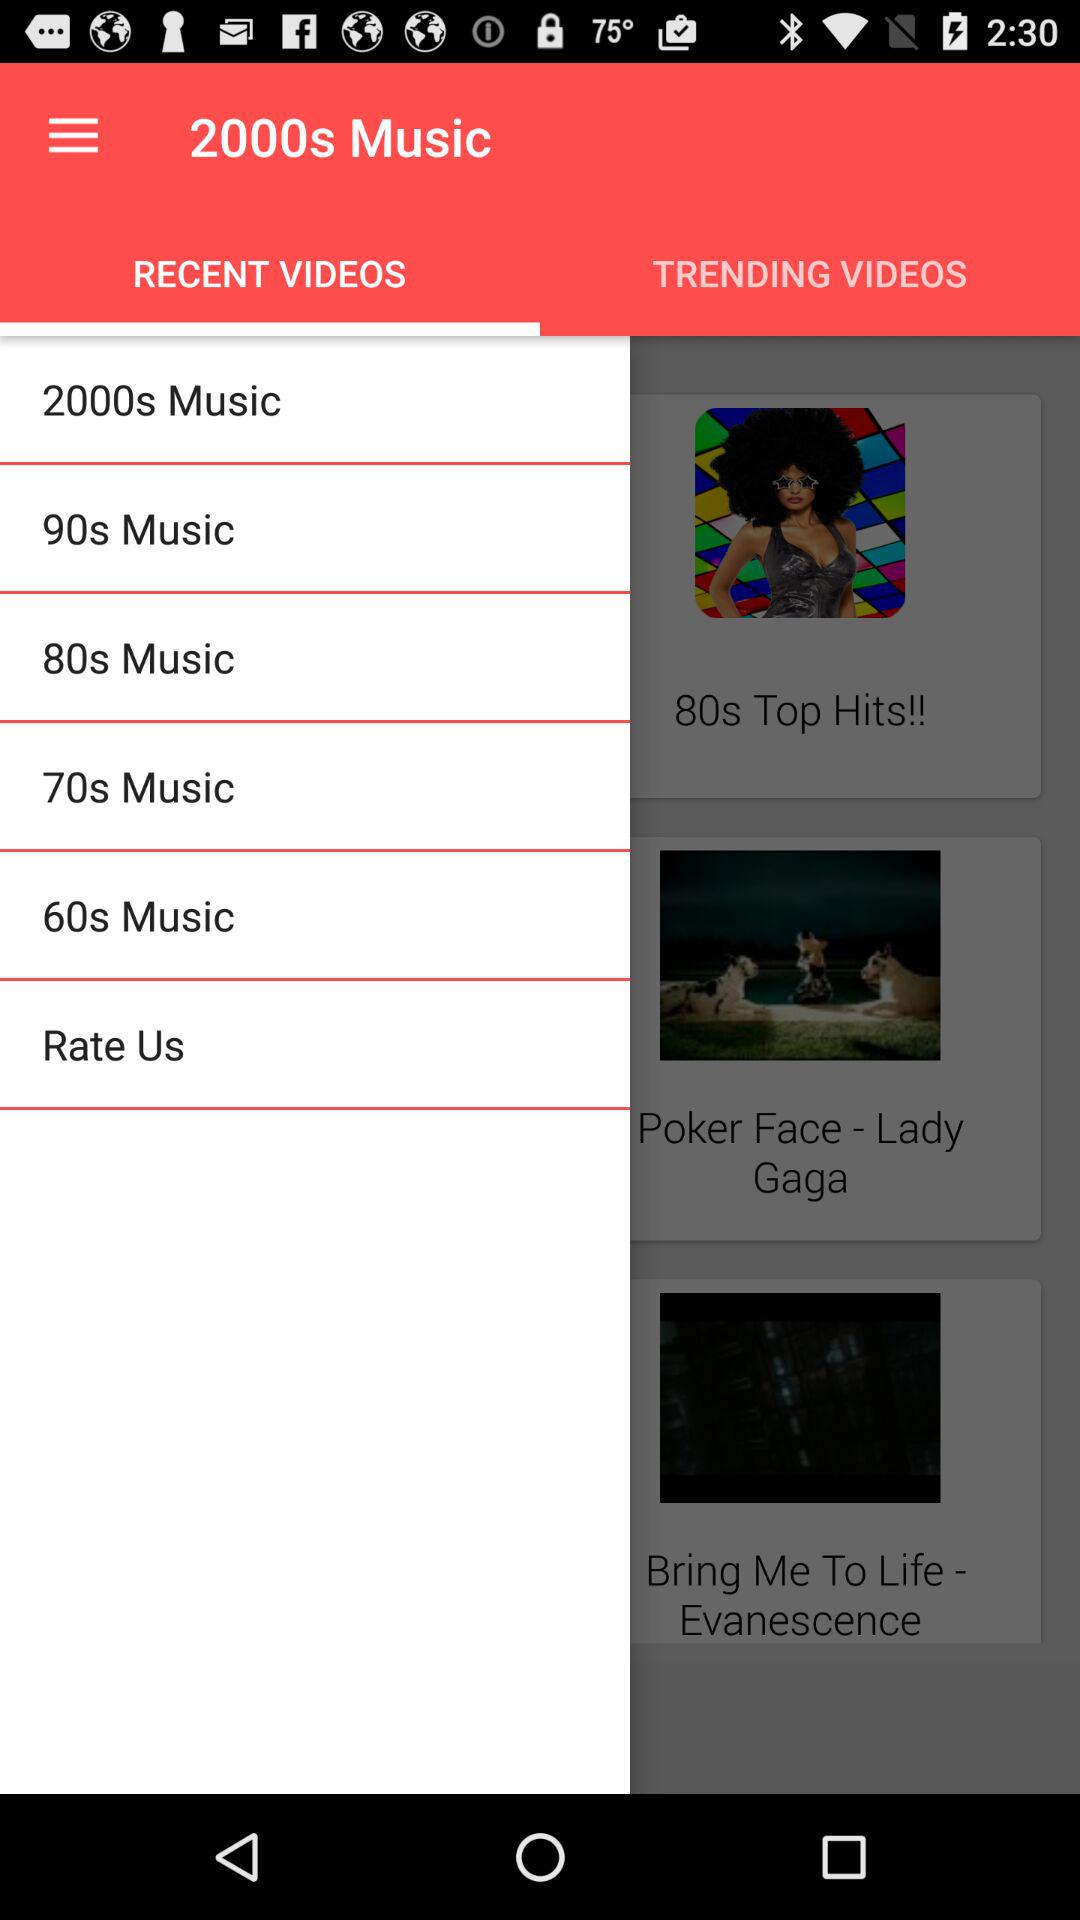What is the application name? The application name shown in the image is '2000s Music'. This app appears to categorize music by decades, offering playlists like '2000s Music', '90s Music', '80s Music', and '70s Music'. 